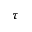<formula> <loc_0><loc_0><loc_500><loc_500>\tau</formula> 